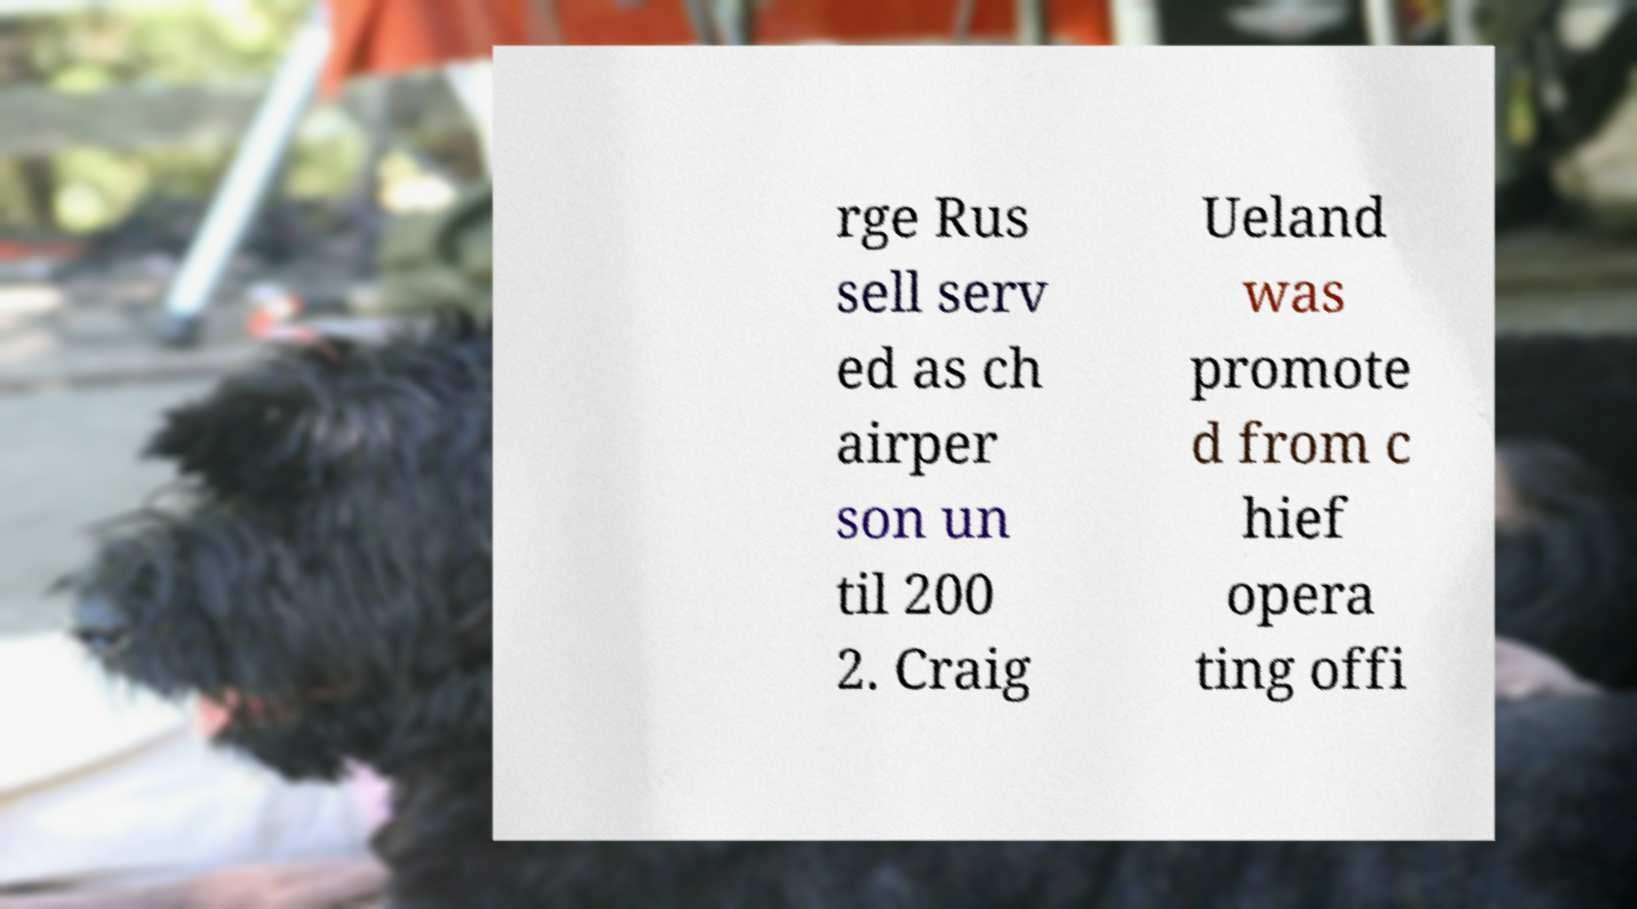There's text embedded in this image that I need extracted. Can you transcribe it verbatim? rge Rus sell serv ed as ch airper son un til 200 2. Craig Ueland was promote d from c hief opera ting offi 